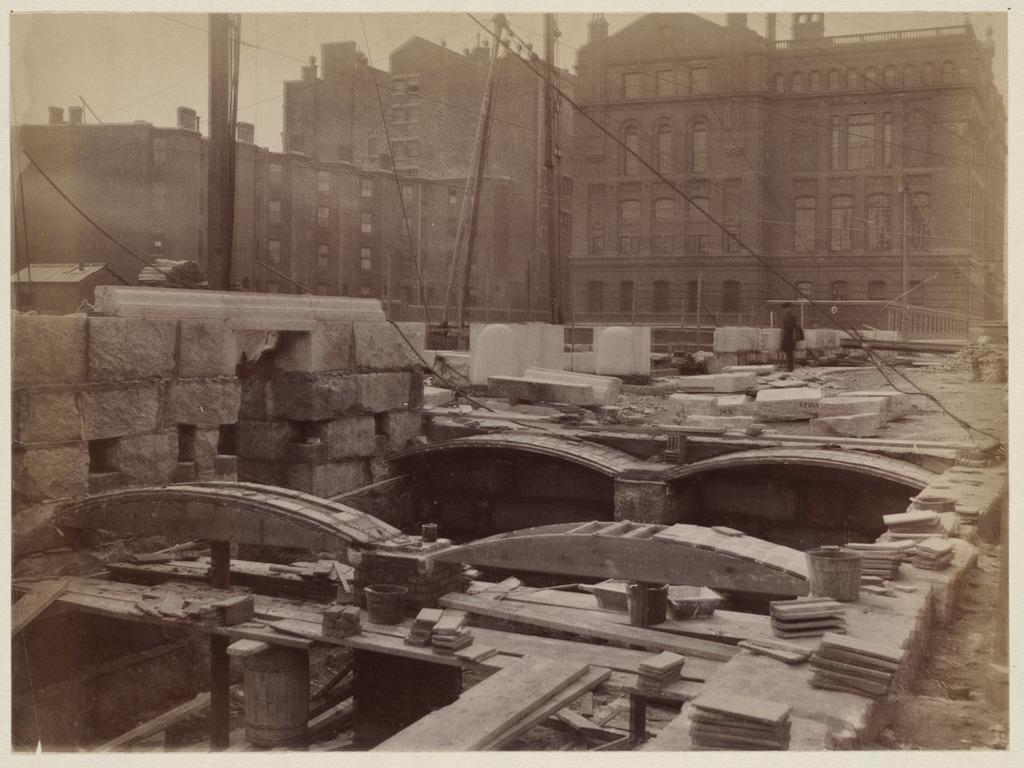Could you give a brief overview of what you see in this image? In this image there is a monument at bottom of this image and there is one person standing at right side of this image and there are some current poles at top of this image and there is a building in the background. 